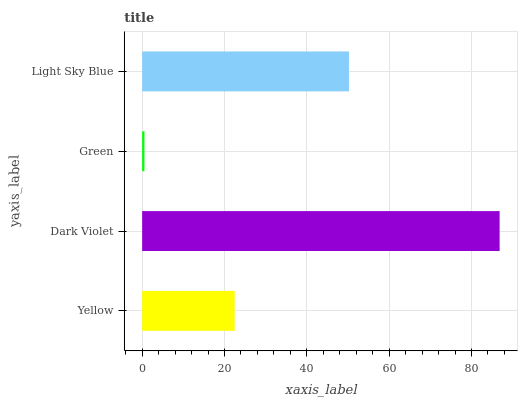Is Green the minimum?
Answer yes or no. Yes. Is Dark Violet the maximum?
Answer yes or no. Yes. Is Dark Violet the minimum?
Answer yes or no. No. Is Green the maximum?
Answer yes or no. No. Is Dark Violet greater than Green?
Answer yes or no. Yes. Is Green less than Dark Violet?
Answer yes or no. Yes. Is Green greater than Dark Violet?
Answer yes or no. No. Is Dark Violet less than Green?
Answer yes or no. No. Is Light Sky Blue the high median?
Answer yes or no. Yes. Is Yellow the low median?
Answer yes or no. Yes. Is Green the high median?
Answer yes or no. No. Is Light Sky Blue the low median?
Answer yes or no. No. 